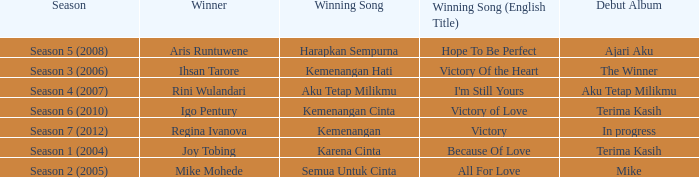I'm looking to parse the entire table for insights. Could you assist me with that? {'header': ['Season', 'Winner', 'Winning Song', 'Winning Song (English Title)', 'Debut Album'], 'rows': [['Season 5 (2008)', 'Aris Runtuwene', 'Harapkan Sempurna', 'Hope To Be Perfect', 'Ajari Aku'], ['Season 3 (2006)', 'Ihsan Tarore', 'Kemenangan Hati', 'Victory Of the Heart', 'The Winner'], ['Season 4 (2007)', 'Rini Wulandari', 'Aku Tetap Milikmu', "I'm Still Yours", 'Aku Tetap Milikmu'], ['Season 6 (2010)', 'Igo Pentury', 'Kemenangan Cinta', 'Victory of Love', 'Terima Kasih'], ['Season 7 (2012)', 'Regina Ivanova', 'Kemenangan', 'Victory', 'In progress'], ['Season 1 (2004)', 'Joy Tobing', 'Karena Cinta', 'Because Of Love', 'Terima Kasih'], ['Season 2 (2005)', 'Mike Mohede', 'Semua Untuk Cinta', 'All For Love', 'Mike']]} Which English winning song had the winner aris runtuwene? Hope To Be Perfect. 